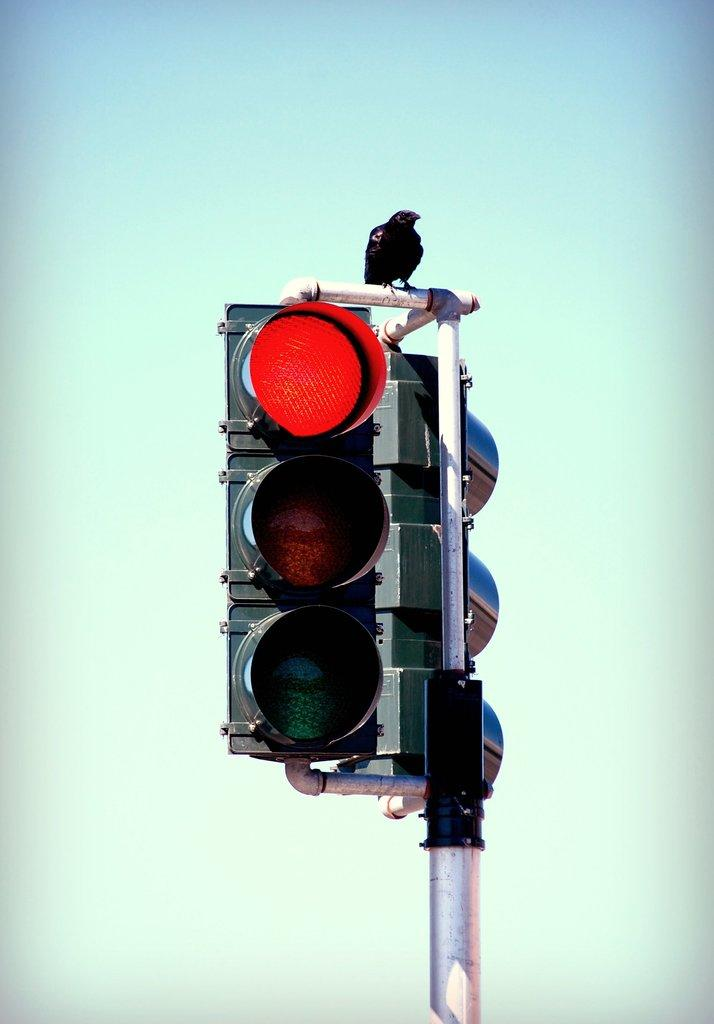What is placed on top of the traffic signals in the image? There is a crown on the traffic signals in the image. What can be seen in the background of the image? The sky is visible in the background of the image. How many women are present in the image? There is no mention of women in the image, so it is not possible to determine their presence or number. 